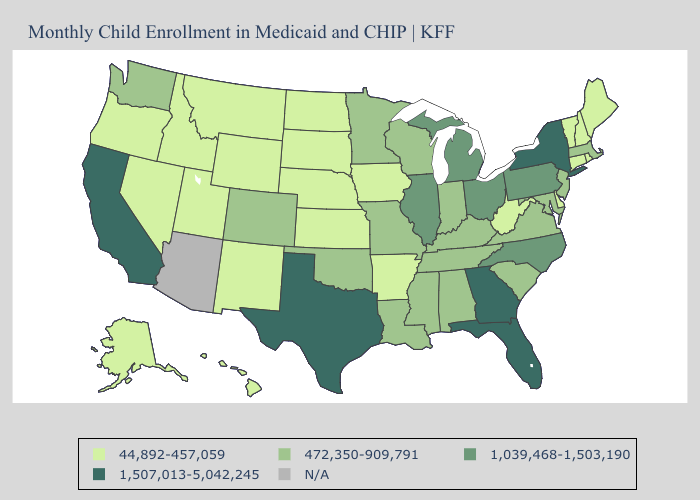What is the highest value in the USA?
Short answer required. 1,507,013-5,042,245. Does Georgia have the highest value in the South?
Quick response, please. Yes. Name the states that have a value in the range 44,892-457,059?
Short answer required. Alaska, Arkansas, Connecticut, Delaware, Hawaii, Idaho, Iowa, Kansas, Maine, Montana, Nebraska, Nevada, New Hampshire, New Mexico, North Dakota, Oregon, Rhode Island, South Dakota, Utah, Vermont, West Virginia, Wyoming. What is the lowest value in states that border Arkansas?
Write a very short answer. 472,350-909,791. Among the states that border Louisiana , which have the lowest value?
Concise answer only. Arkansas. What is the value of New Mexico?
Answer briefly. 44,892-457,059. Name the states that have a value in the range N/A?
Be succinct. Arizona. What is the lowest value in states that border North Dakota?
Concise answer only. 44,892-457,059. Which states hav the highest value in the Northeast?
Short answer required. New York. Name the states that have a value in the range 472,350-909,791?
Be succinct. Alabama, Colorado, Indiana, Kentucky, Louisiana, Maryland, Massachusetts, Minnesota, Mississippi, Missouri, New Jersey, Oklahoma, South Carolina, Tennessee, Virginia, Washington, Wisconsin. Among the states that border Wisconsin , does Michigan have the highest value?
Give a very brief answer. Yes. What is the lowest value in states that border Idaho?
Be succinct. 44,892-457,059. Among the states that border Colorado , which have the lowest value?
Keep it brief. Kansas, Nebraska, New Mexico, Utah, Wyoming. Does the map have missing data?
Short answer required. Yes. Name the states that have a value in the range 472,350-909,791?
Short answer required. Alabama, Colorado, Indiana, Kentucky, Louisiana, Maryland, Massachusetts, Minnesota, Mississippi, Missouri, New Jersey, Oklahoma, South Carolina, Tennessee, Virginia, Washington, Wisconsin. 